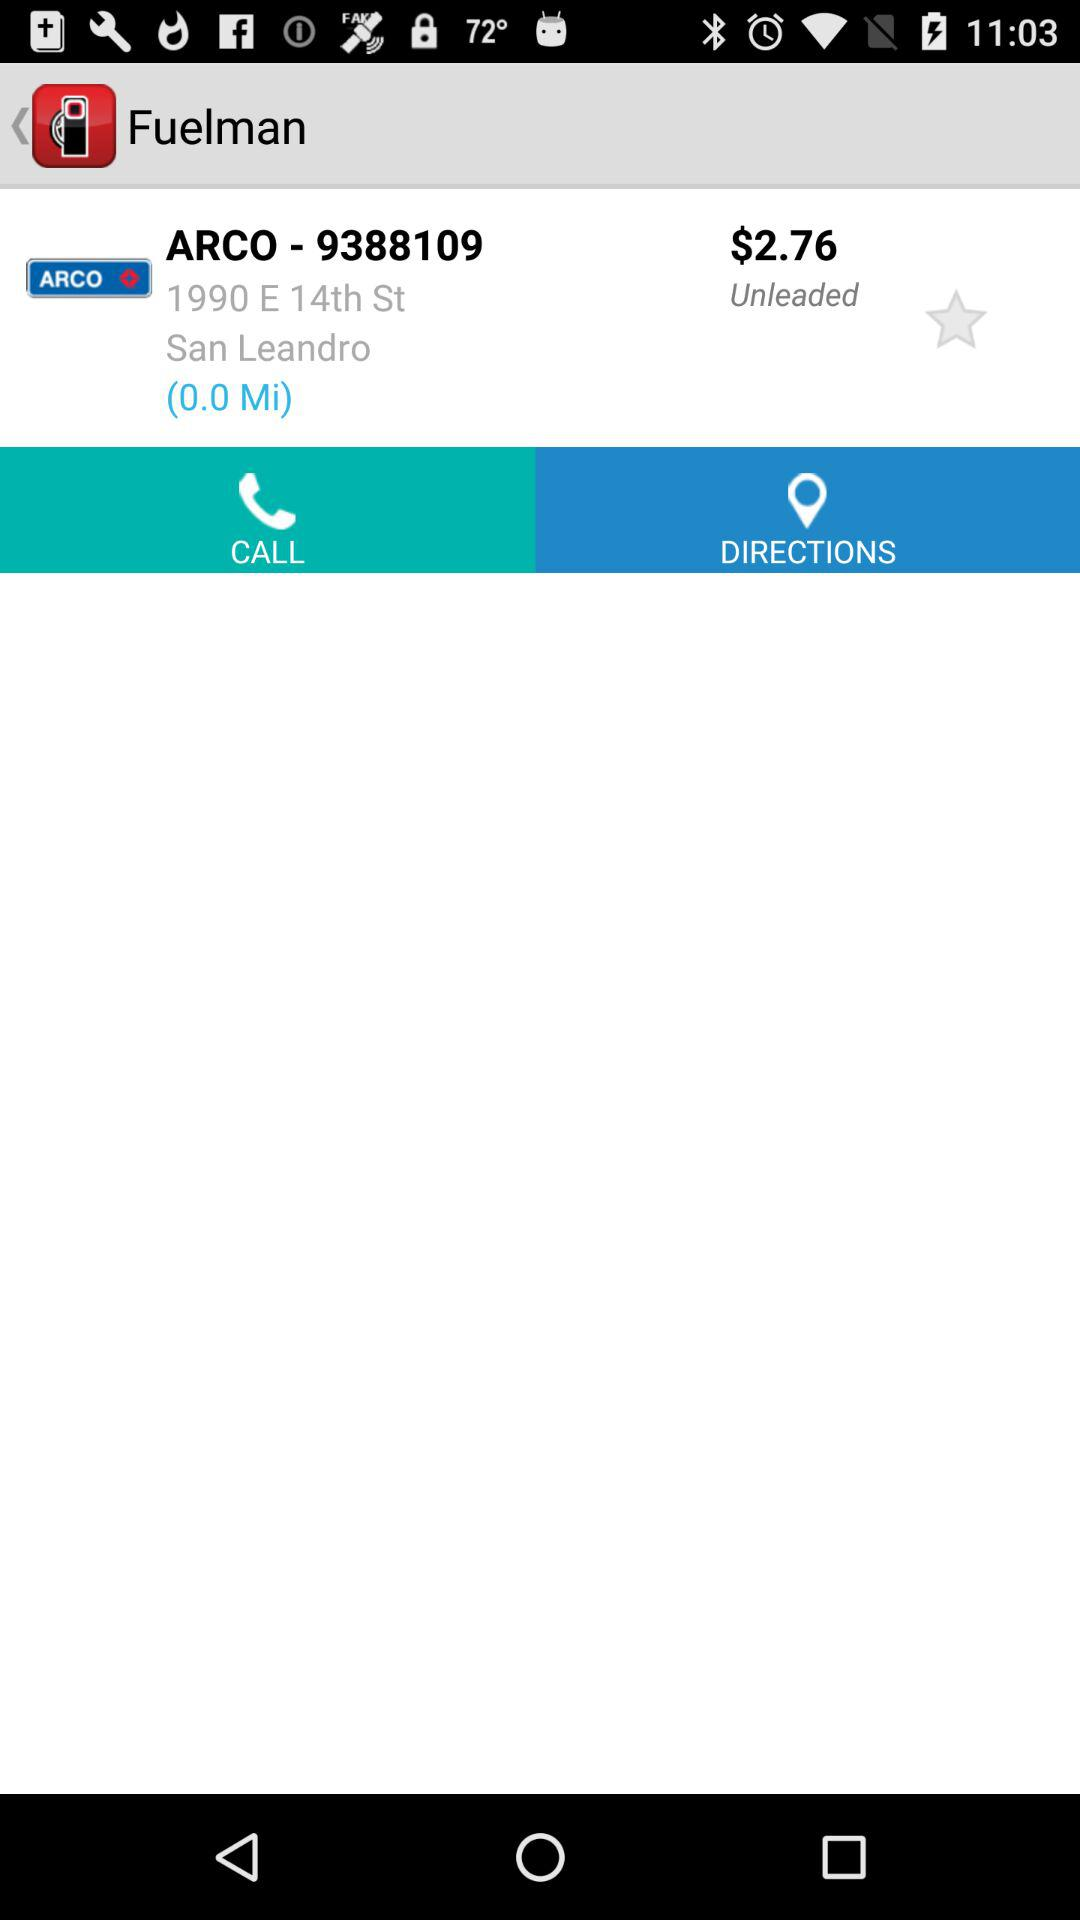What is the location of "ARCO - 9388109"? The location is 1990 E 14th St., San Leandro. 